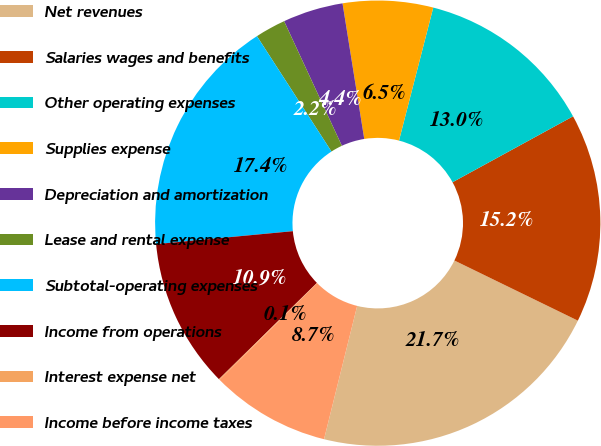Convert chart. <chart><loc_0><loc_0><loc_500><loc_500><pie_chart><fcel>Net revenues<fcel>Salaries wages and benefits<fcel>Other operating expenses<fcel>Supplies expense<fcel>Depreciation and amortization<fcel>Lease and rental expense<fcel>Subtotal-operating expenses<fcel>Income from operations<fcel>Interest expense net<fcel>Income before income taxes<nl><fcel>21.66%<fcel>15.18%<fcel>13.02%<fcel>6.54%<fcel>4.38%<fcel>2.22%<fcel>17.37%<fcel>10.86%<fcel>0.06%<fcel>8.7%<nl></chart> 